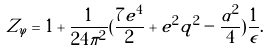Convert formula to latex. <formula><loc_0><loc_0><loc_500><loc_500>Z _ { \varphi } = 1 + \frac { 1 } { 2 4 \pi ^ { 2 } } ( \frac { 7 e ^ { 4 } } 2 + e ^ { 2 } q ^ { 2 } - \frac { \alpha ^ { 2 } } { 4 } ) \frac { 1 } { \epsilon } .</formula> 